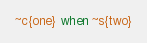<code> <loc_0><loc_0><loc_500><loc_500><_Elixir_>~c{one} when ~s{two}</code> 